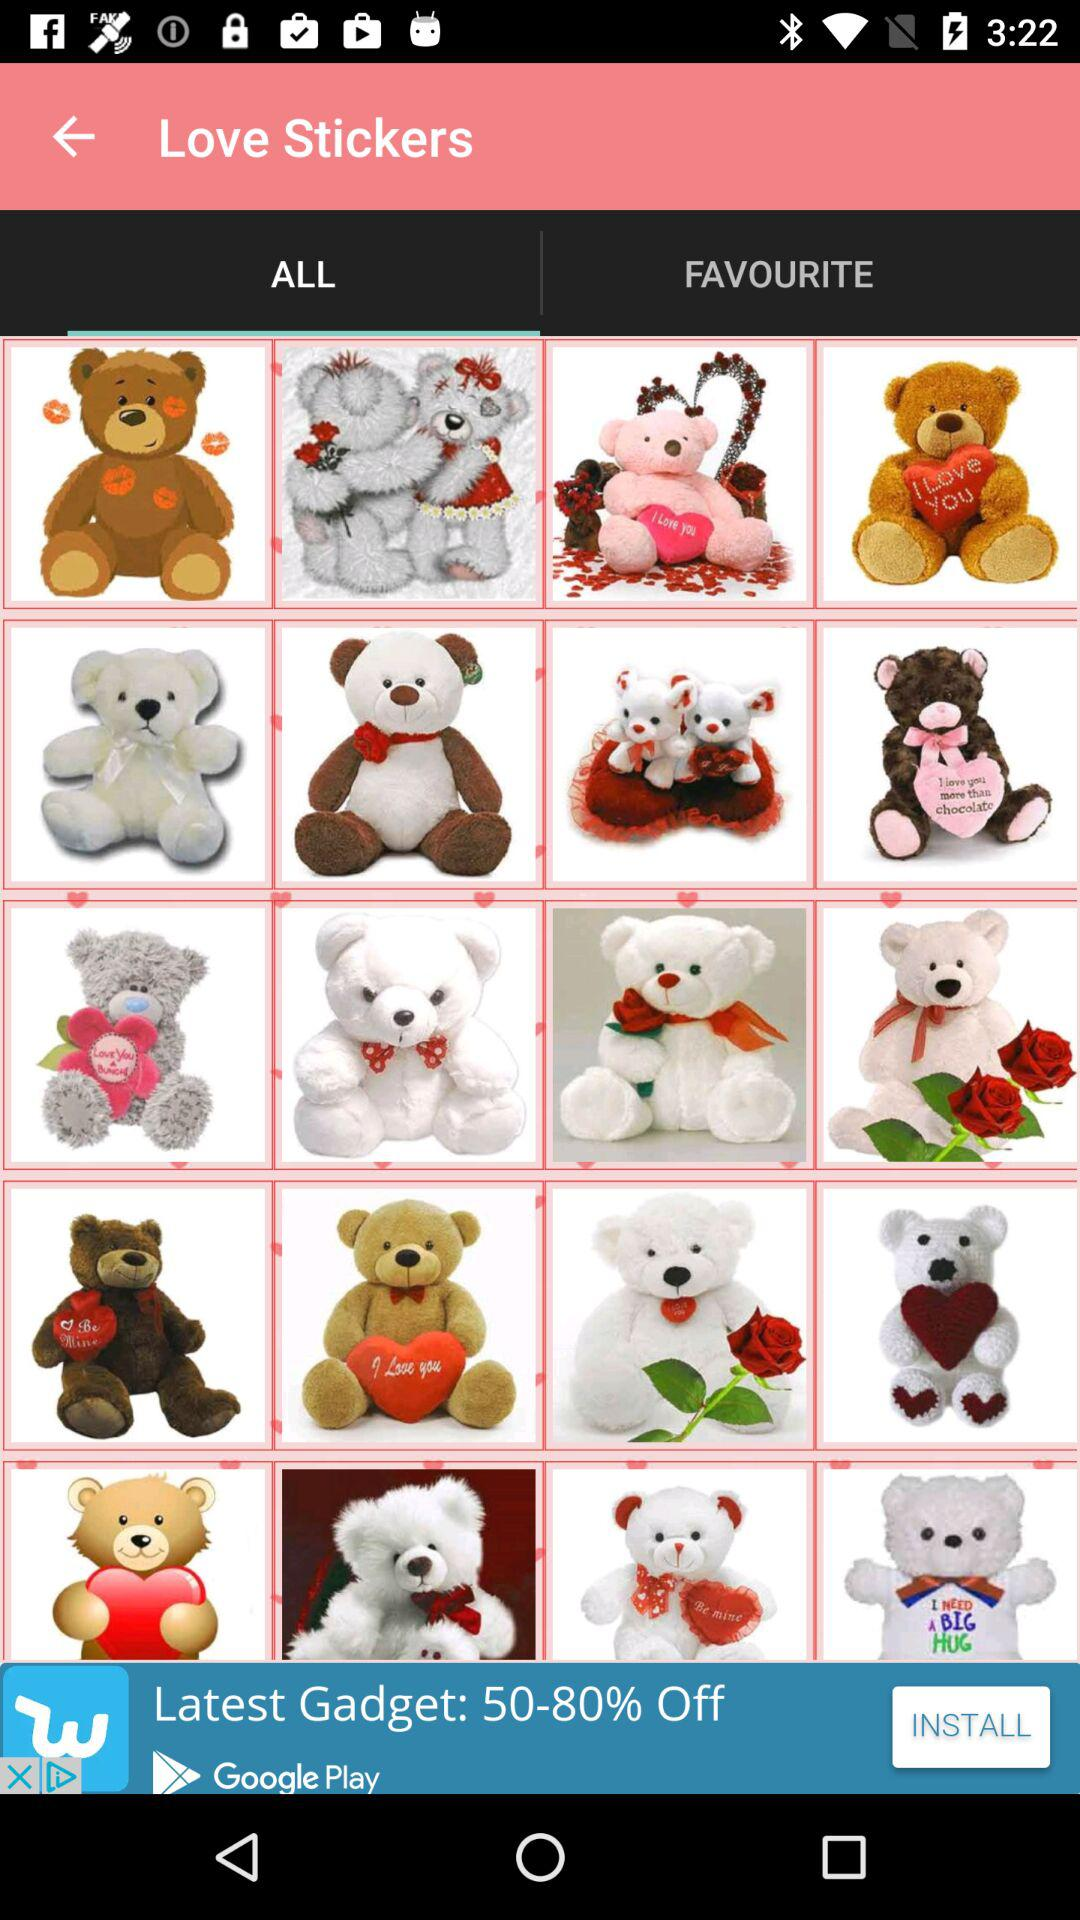Which tab has been selected? The tab that has been selected is "ALL". 